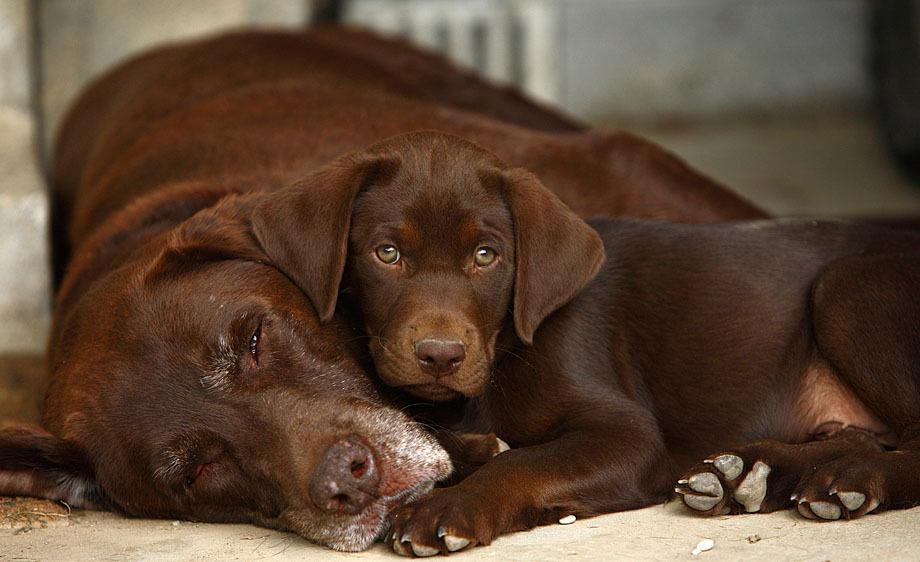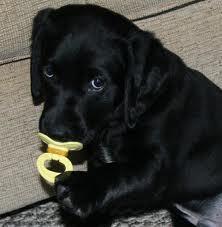The first image is the image on the left, the second image is the image on the right. Examine the images to the left and right. Is the description "One image contains exactly one reclining chocolate-brown dog." accurate? Answer yes or no. No. The first image is the image on the left, the second image is the image on the right. For the images shown, is this caption "There is one black dog that has its mouth open in one of the images." true? Answer yes or no. No. 